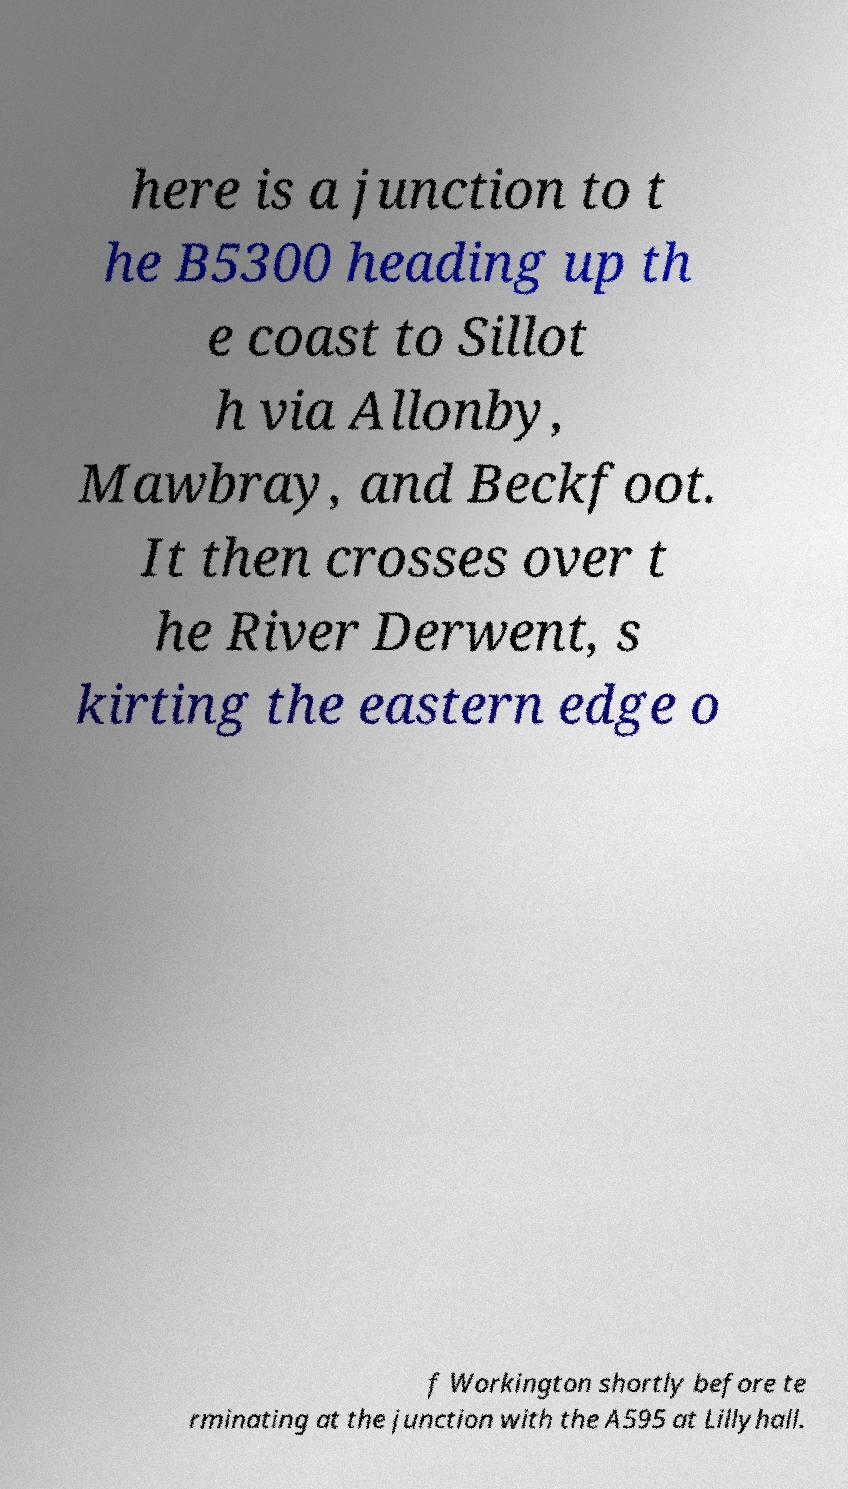Could you extract and type out the text from this image? here is a junction to t he B5300 heading up th e coast to Sillot h via Allonby, Mawbray, and Beckfoot. It then crosses over t he River Derwent, s kirting the eastern edge o f Workington shortly before te rminating at the junction with the A595 at Lillyhall. 